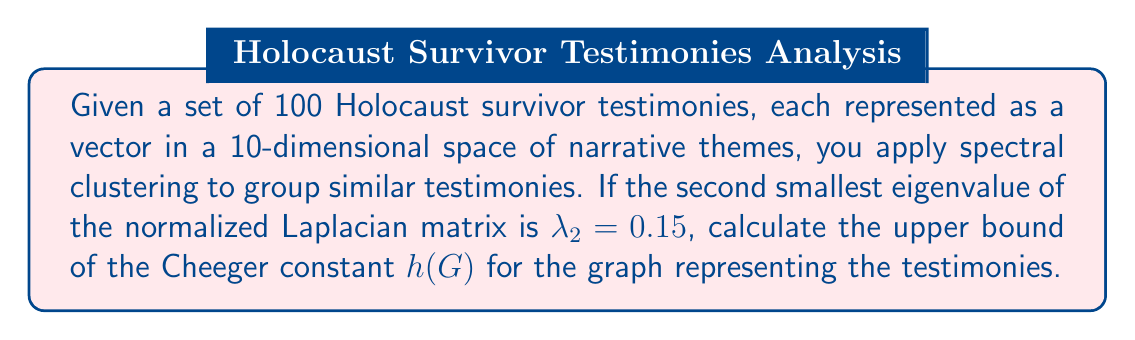Can you answer this question? To solve this problem, we'll follow these steps:

1) Recall the relationship between the Cheeger constant $h(G)$ and the second smallest eigenvalue $\lambda_2$ of the normalized Laplacian matrix:

   $$h(G) \leq \sqrt{2\lambda_2}$$

2) We are given that $\lambda_2 = 0.15$

3) Substitute this value into the inequality:

   $$h(G) \leq \sqrt{2(0.15)}$$

4) Simplify inside the square root:

   $$h(G) \leq \sqrt{0.3}$$

5) Calculate the square root:

   $$h(G) \leq 0.5477$$

This upper bound on the Cheeger constant suggests that the testimonies can be partitioned into two groups with relatively low connectivity between them, indicating distinct clusters of narrative themes in the survivors' stories.
Answer: $0.5477$ 